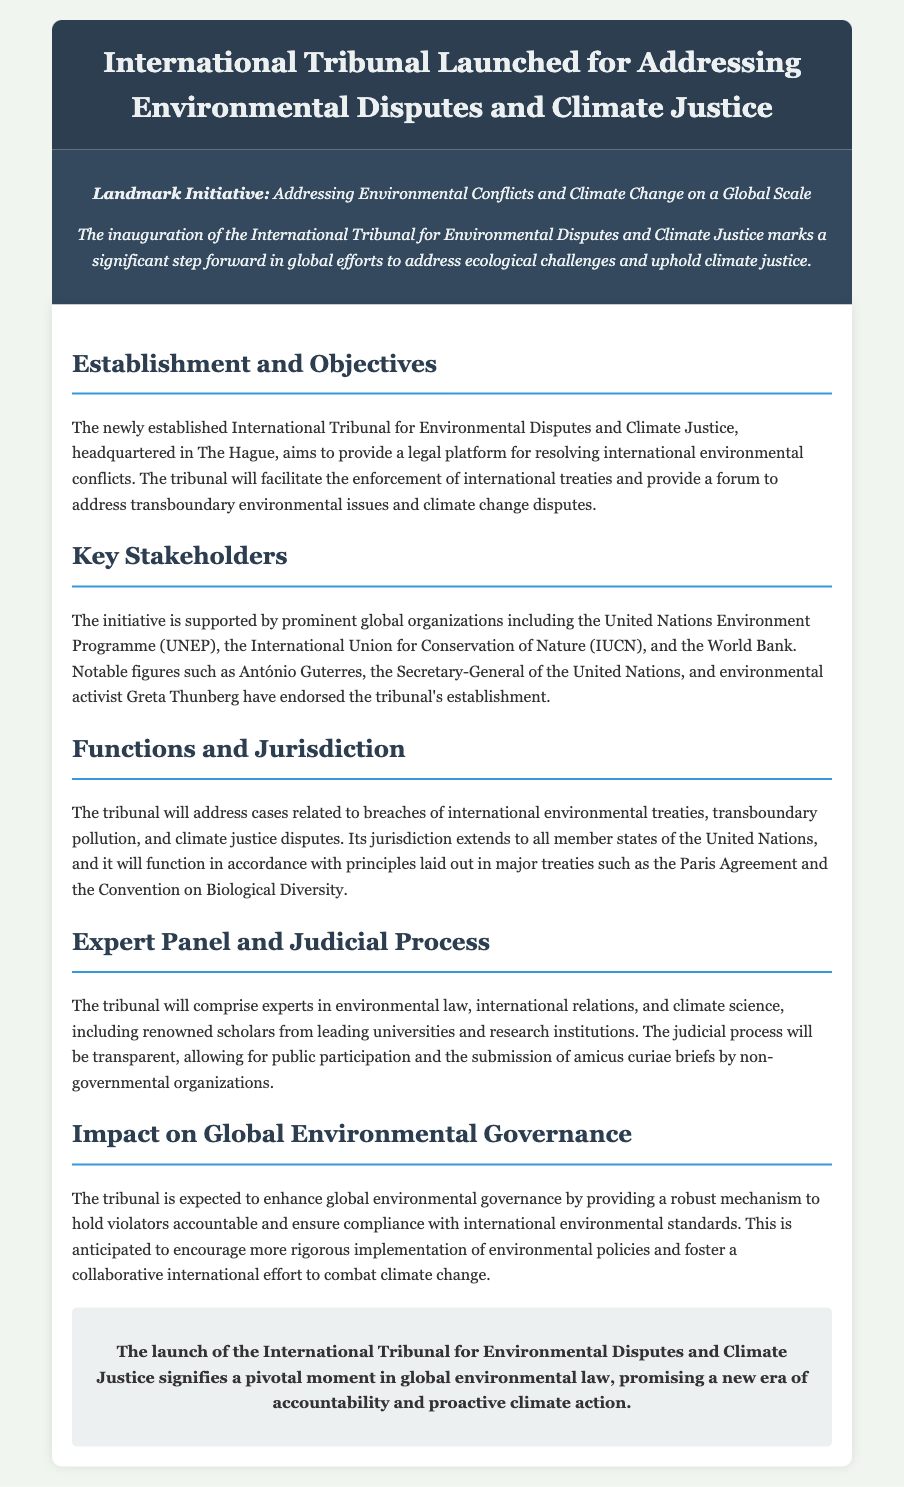What is the location of the International Tribunal? The document states that the tribunal is headquartered in The Hague.
Answer: The Hague Who endorsed the tribunal's establishment? Notable figures mentioned in the document include António Guterres and Greta Thunberg.
Answer: António Guterres, Greta Thunberg What is one of the key functions of the tribunal? The tribunal addresses breaches of international environmental treaties as mentioned in the functions section.
Answer: Breaches of international environmental treaties Which organizations support the tribunal? The document identifies organizations such as UNEP, IUCN, and the World Bank as supporters.
Answer: UNEP, IUCN, World Bank What type of experts will comprise the tribunal? The document specifies that the tribunal will consist of experts in environmental law, international relations, and climate science.
Answer: Experts in environmental law, international relations, and climate science What principle will guide the tribunal's functions? The tribunal will function in accordance with principles laid out in the Paris Agreement and the Convention on Biological Diversity.
Answer: Paris Agreement and Convention on Biological Diversity How is the judicial process described in the document? The judicial process is described as transparent, allowing public participation and submission of amicus curiae briefs.
Answer: Transparent What is a potential impact of the tribunal on global governance? The tribunal is expected to enhance global environmental governance and ensure compliance with international environmental standards.
Answer: Enhance global environmental governance What is a significant outcome expected from the tribunal? The launch of the tribunal is expected to signify a pivotal moment in global environmental law.
Answer: Pivotal moment in global environmental law 